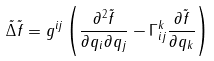<formula> <loc_0><loc_0><loc_500><loc_500>\tilde { \Delta } \tilde { f } = g ^ { i j } \left ( \frac { \partial ^ { 2 } \tilde { f } } { \partial q _ { i } \partial q _ { j } } - \Gamma _ { i j } ^ { k } \frac { \partial \tilde { f } } { \partial q _ { k } } \right )</formula> 